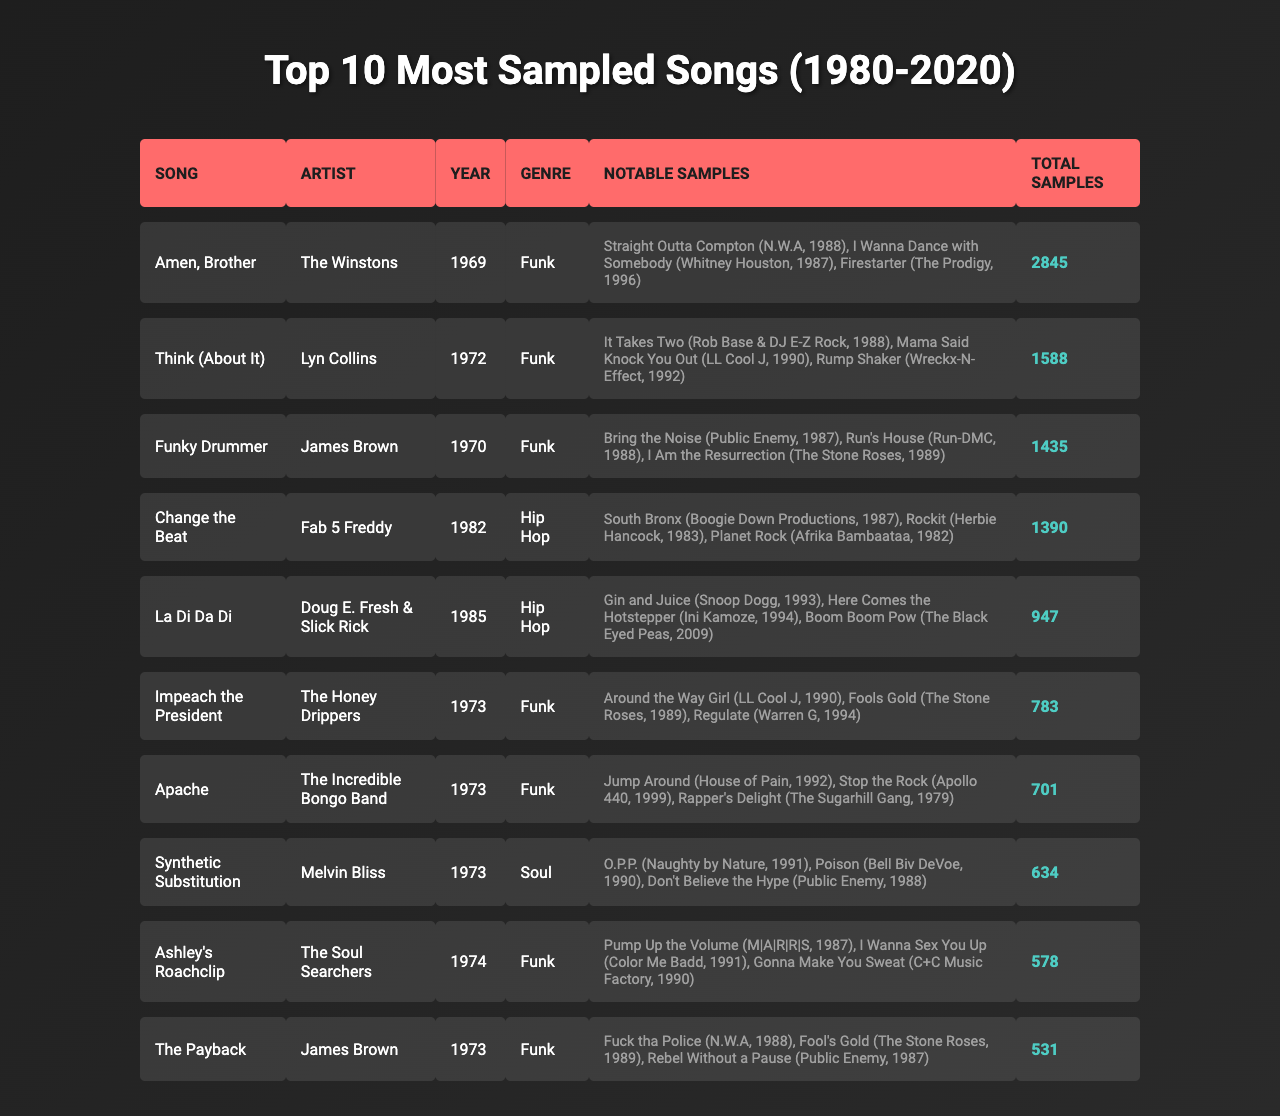What is the most sampled song from the table? The table shows that "Amen, Brother" by The Winstons has the highest total samples at 2845.
Answer: Amen, Brother Which artist has the most sampled song in the Funk genre? "Amen, Brother" is the most sampled song in the Funk genre as it has the highest total samples of 2845.
Answer: The Winstons How many total samples does "La Di Da Di" have? The table states that "La Di Da Di" has a total of 947 samples.
Answer: 947 Which song from the table was released earliest? The earliest song listed is "Amen, Brother" from 1969 by The Winstons.
Answer: Amen, Brother What is the average number of total samples for the songs listed? The total samples for all songs is 6,390 (2845 + 1588 + 1435 + 1390 + 947 + 783 + 701 + 634 + 578 + 531 = 6390), and there are 10 songs, so the average is 6390 / 10 = 639.
Answer: 639 Does "Synthetic Substitution" feature songs that are more recent than 1990? The notable samples listed for "Synthetic Substitution" include "O.P.P." (1991) and "Poison" (1990), making the answer true.
Answer: Yes How many songs in the Hip Hop genre are listed in the table? The table includes 2 songs in the Hip Hop genre: "Change the Beat" and "La Di Da Di."
Answer: 2 What is the difference in total samples between the most sampled song and the least sampled song? The most sampled song "Amen, Brother" has 2845 total samples, while "The Payback" has 531 total samples. The difference is 2845 - 531 = 2314.
Answer: 2314 Is "Apache" sampled by more songs than "Funky Drummer"? "Apache" has a total of 701 samples, while "Funky Drummer" has 1435 samples, so the answer is false.
Answer: No Which song by James Brown has a higher number of samples? Among the two songs by James Brown, "Funky Drummer" has 1435 samples, while "The Payback" has 531, making "Funky Drummer" the song with a higher sample count.
Answer: Funky Drummer 